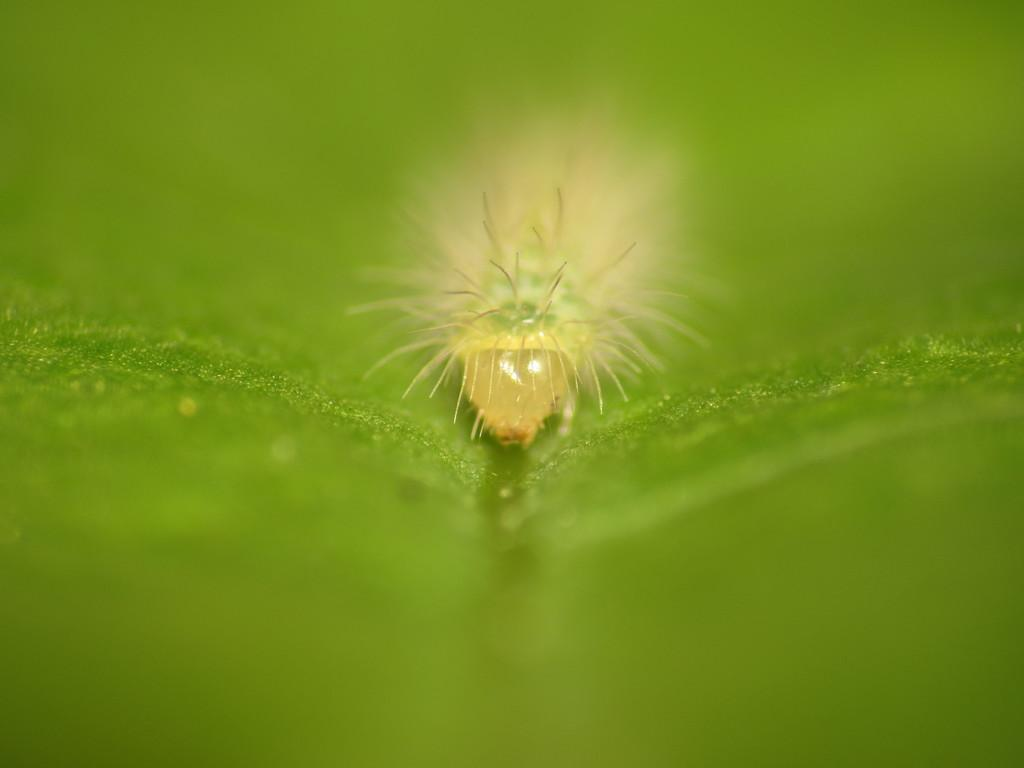What is the main subject of the image? The main subject of the image is an insect-like thing. What is the insect-like thing located on? The insect-like thing is on a green color object. What type of manager is overseeing the sheet in the image? There is no manager or sheet present in the image; it only features an insect-like thing on a green color object. 